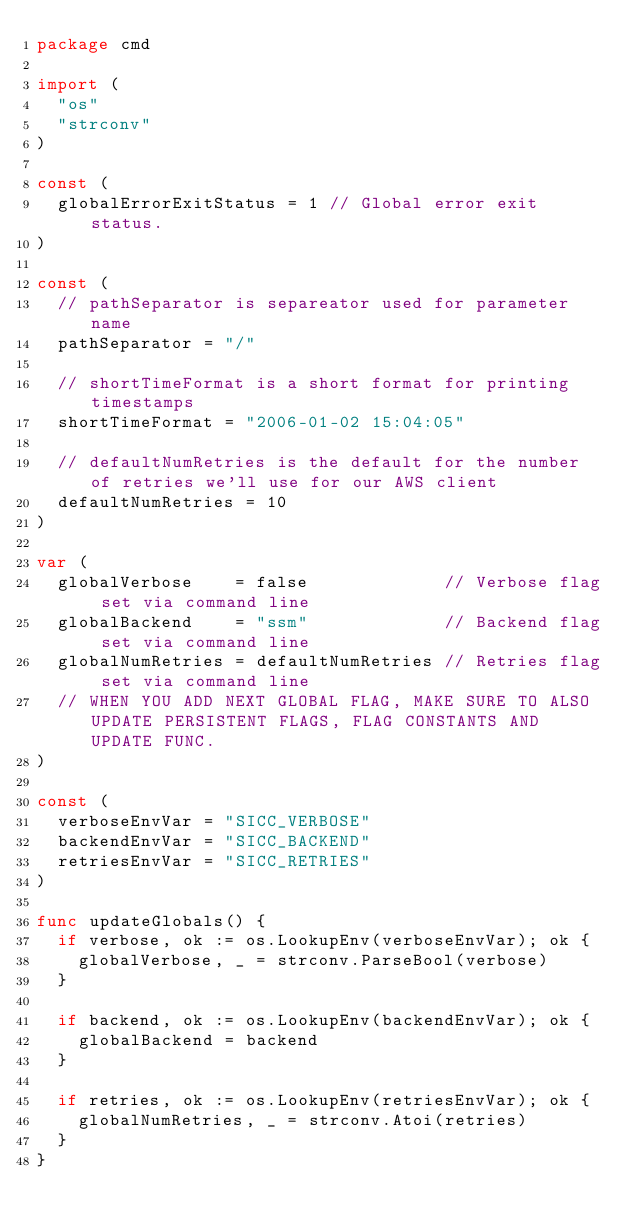<code> <loc_0><loc_0><loc_500><loc_500><_Go_>package cmd

import (
	"os"
	"strconv"
)

const (
	globalErrorExitStatus = 1 // Global error exit status.
)

const (
	// pathSeparator is separeator used for parameter name
	pathSeparator = "/"

	// shortTimeFormat is a short format for printing timestamps
	shortTimeFormat = "2006-01-02 15:04:05"

	// defaultNumRetries is the default for the number of retries we'll use for our AWS client
	defaultNumRetries = 10
)

var (
	globalVerbose    = false             // Verbose flag set via command line
	globalBackend    = "ssm"             // Backend flag set via command line
	globalNumRetries = defaultNumRetries // Retries flag set via command line
	// WHEN YOU ADD NEXT GLOBAL FLAG, MAKE SURE TO ALSO UPDATE PERSISTENT FLAGS, FLAG CONSTANTS AND UPDATE FUNC.
)

const (
	verboseEnvVar = "SICC_VERBOSE"
	backendEnvVar = "SICC_BACKEND"
	retriesEnvVar = "SICC_RETRIES"
)

func updateGlobals() {
	if verbose, ok := os.LookupEnv(verboseEnvVar); ok {
		globalVerbose, _ = strconv.ParseBool(verbose)
	}

	if backend, ok := os.LookupEnv(backendEnvVar); ok {
		globalBackend = backend
	}

	if retries, ok := os.LookupEnv(retriesEnvVar); ok {
		globalNumRetries, _ = strconv.Atoi(retries)
	}
}
</code> 